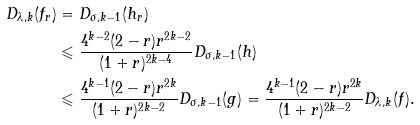Convert formula to latex. <formula><loc_0><loc_0><loc_500><loc_500>D _ { \lambda , k } ( f _ { r } ) & = D _ { \sigma , k - 1 } ( h _ { r } ) \\ & \leqslant \frac { 4 ^ { k - 2 } ( 2 - r ) r ^ { 2 k - 2 } } { ( 1 + r ) ^ { 2 k - 4 } } D _ { \sigma , k - 1 } ( h ) \\ & \leqslant \frac { 4 ^ { k - 1 } ( 2 - r ) r ^ { 2 k } } { ( 1 + r ) ^ { 2 k - 2 } } D _ { \sigma , k - 1 } ( g ) = \frac { 4 ^ { k - 1 } ( 2 - r ) r ^ { 2 k } } { ( 1 + r ) ^ { 2 k - 2 } } D _ { \lambda , k } ( f ) .</formula> 